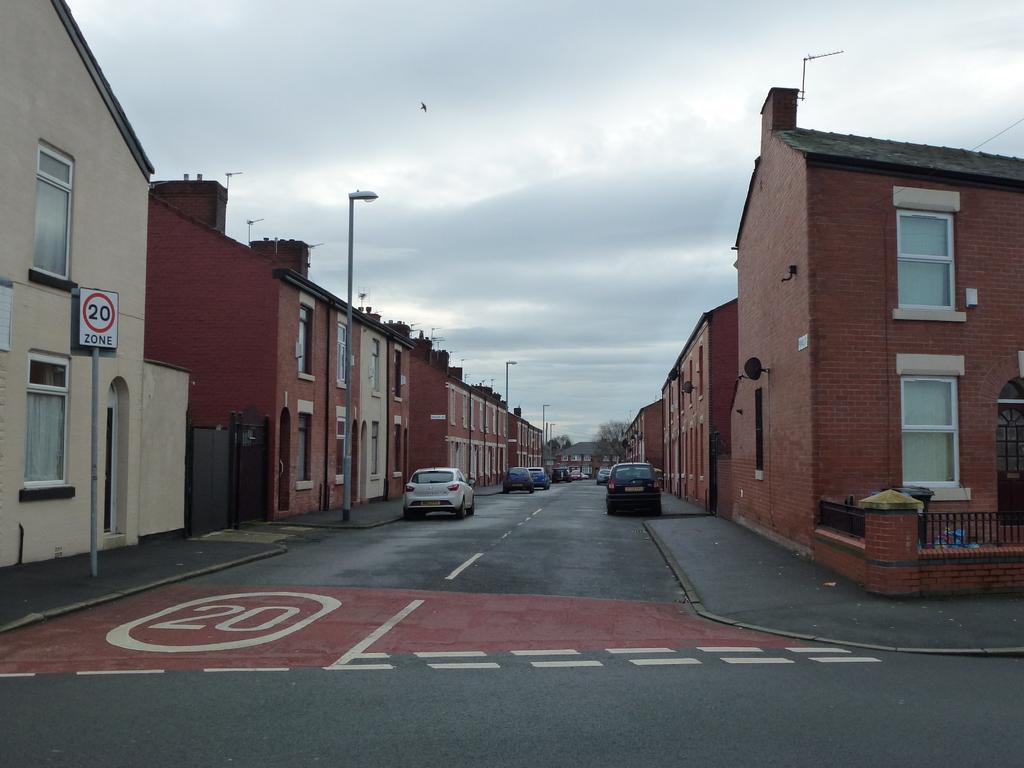Describe this image in one or two sentences. This image is taken out side of the road in the central there are cars parked on the road. On the left side there are buildings and there are poles, and on the right side there are buildings which are red in colour and the sky is cloudy. 